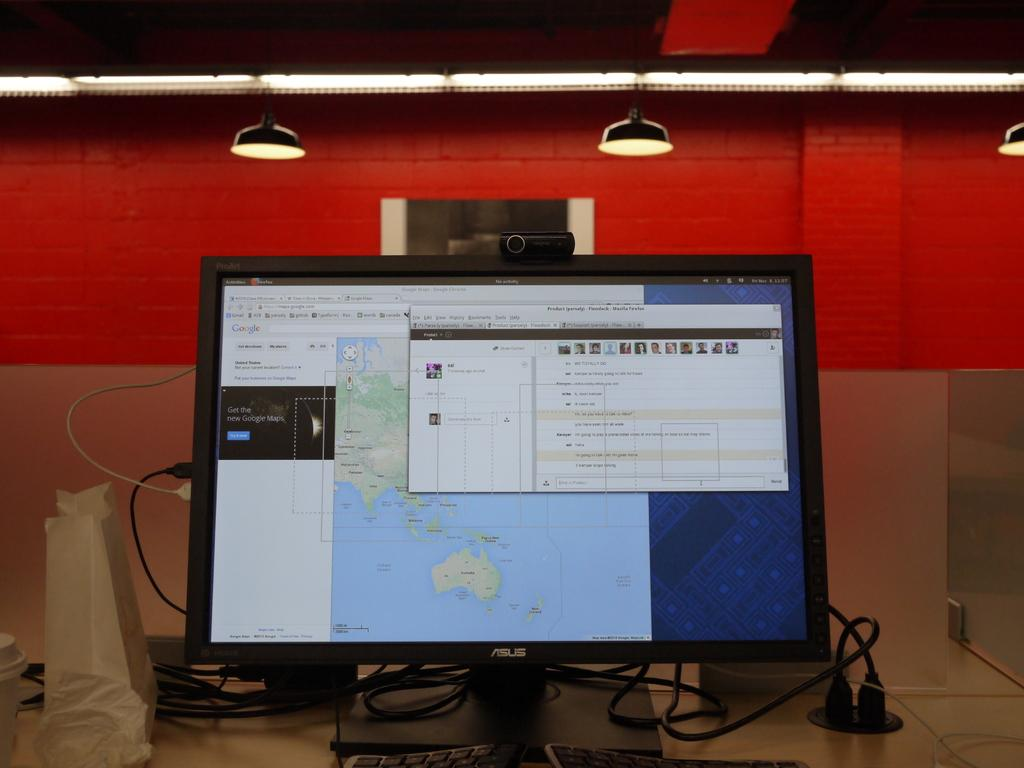<image>
Offer a succinct explanation of the picture presented. The computer shown is opened to a google maps page. 